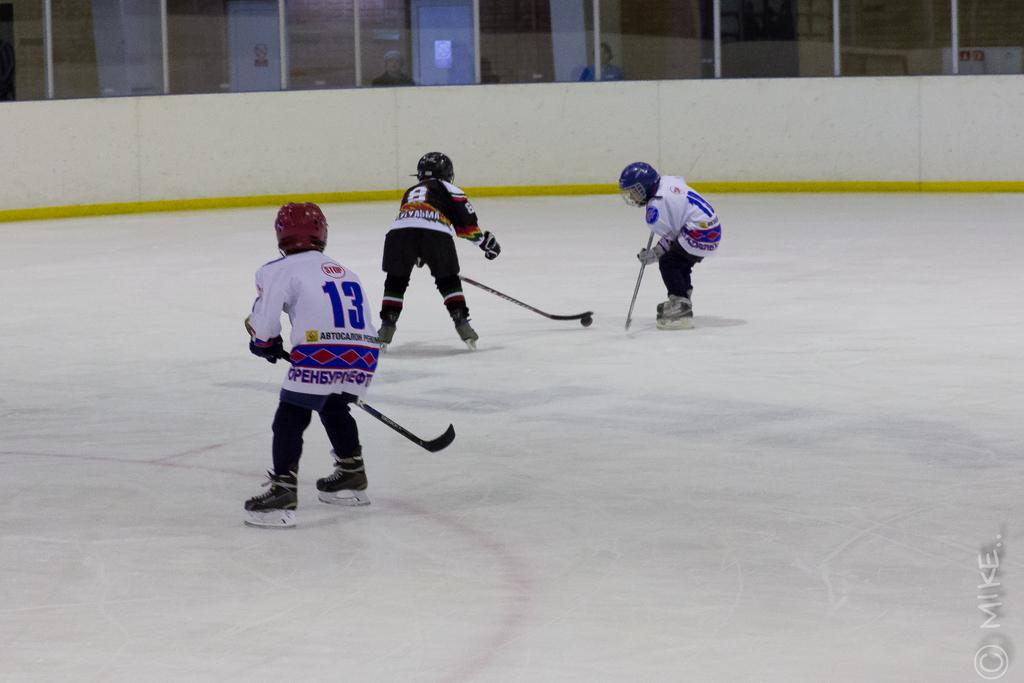What are the persons in the image doing? The persons in the image are playing in the center of the image. What can be seen in the background of the image? There is a mirror in the background of the image. Can you describe what is visible behind the mirror? There are persons visible behind the mirror. How many dimes can be seen on the zebra in the image? There is no zebra or dimes present in the image. What type of bulb is illuminating the persons playing in the image? The image does not provide information about any bulbs or lighting sources. 